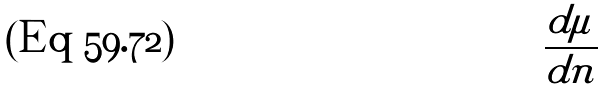Convert formula to latex. <formula><loc_0><loc_0><loc_500><loc_500>\frac { d \mu } { d n }</formula> 